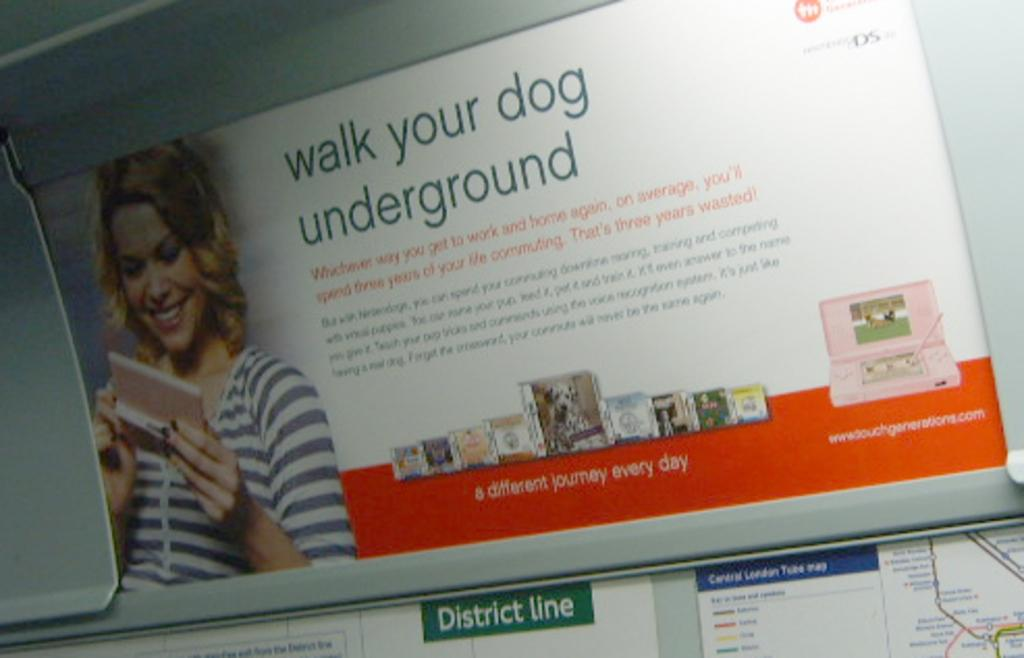What can be seen on the posters in the image? There are posters in the image, and on one of them, there is a woman. What is the woman doing in the image? The woman is smiling in the image. Is there any text on the poster with the woman? Yes, there is text written on the poster with the woman. Can you see the woman's feet in the image? There is no information about the woman's feet in the provided facts, so we cannot determine if they are visible in the image. 